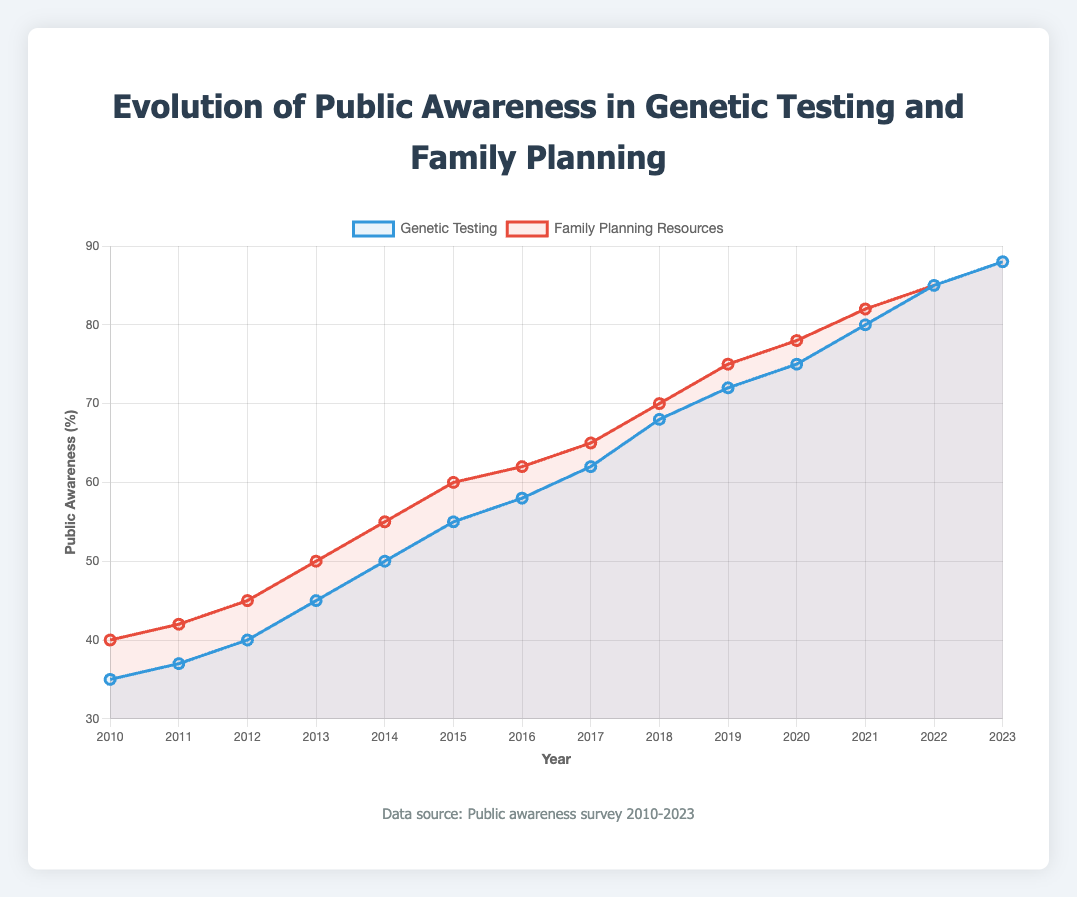What trend is observed in public awareness of genetic testing from 2010 to 2023? The plot shows a steady upward trend in public awareness of genetic testing, starting at 35% in 2010 and increasing to 88% in 2023.
Answer: An increasing trend What year did public awareness of family planning resources first reach 70%? By examining the plot, the public awareness of family planning resources reached 70% in the year 2018.
Answer: 2018 Which year showed the greatest increase in public awareness for genetic testing compared to the previous year? By observing the plot, the greatest yearly increase for genetic testing occurred between 2020 and 2021, where it rose from 75% to 80%, an increase of 5%.
Answer: 2020 to 2021 In what year did public awareness of both genetic testing and family planning resources become equal? By looking at the plot, we see that in 2022, the public awareness for both genetic testing and family planning resources was equal at 85%.
Answer: 2022 Between which two years did public awareness of family planning resources see the highest growth rate? The highest yearly growth rate for family planning resources seems to occur between 2012 and 2013, where it increased from 45% to 50%, a 5% growth.
Answer: 2012 to 2013 What is the average public awareness percentage for genetic testing over the years 2015 to 2019? The average public awareness is calculated by adding the values of genetic testing awareness from 2015 to 2019 (55 + 58 + 62 + 68 + 72) and then dividing by the number of years (5). The sum is 315, so the average is 315/5 = 63%.
Answer: 63% How much did public awareness of family planning resources increase between 2010 and 2023? To find the increase, we subtract the 2010 value from the 2023 value: 88% - 40% = 48%.
Answer: 48% By how many points did awareness of genetic testing improve from 2010 to 2020? To calculate the improvement, subtract the 2010 value from the 2020 value: 75% - 35% = 40%.
Answer: 40% Which awareness, genetic testing or family planning resources, had a higher growth rate from 2010 to 2023? For genetic testing, the increase is from 35% to 88%, making the growth 88% - 35% = 53%. For family planning, the increase is from 40% to 88%, making the growth 88% - 40% = 48%. Genetic testing had a higher growth rate of 53%.
Answer: Genetic testing 